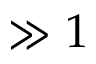<formula> <loc_0><loc_0><loc_500><loc_500>\gg 1</formula> 